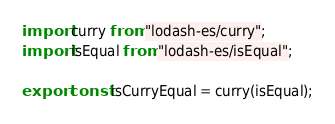<code> <loc_0><loc_0><loc_500><loc_500><_TypeScript_>import curry from "lodash-es/curry";
import isEqual from "lodash-es/isEqual";

export const isCurryEqual = curry(isEqual);
</code> 